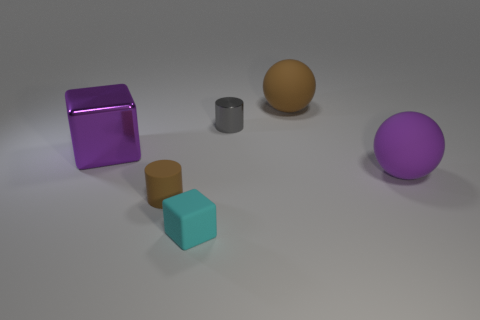Add 4 small blue spheres. How many objects exist? 10 Subtract all balls. How many objects are left? 4 Subtract 1 cyan cubes. How many objects are left? 5 Subtract all gray cylinders. Subtract all purple metal things. How many objects are left? 4 Add 4 tiny cylinders. How many tiny cylinders are left? 6 Add 4 small green matte objects. How many small green matte objects exist? 4 